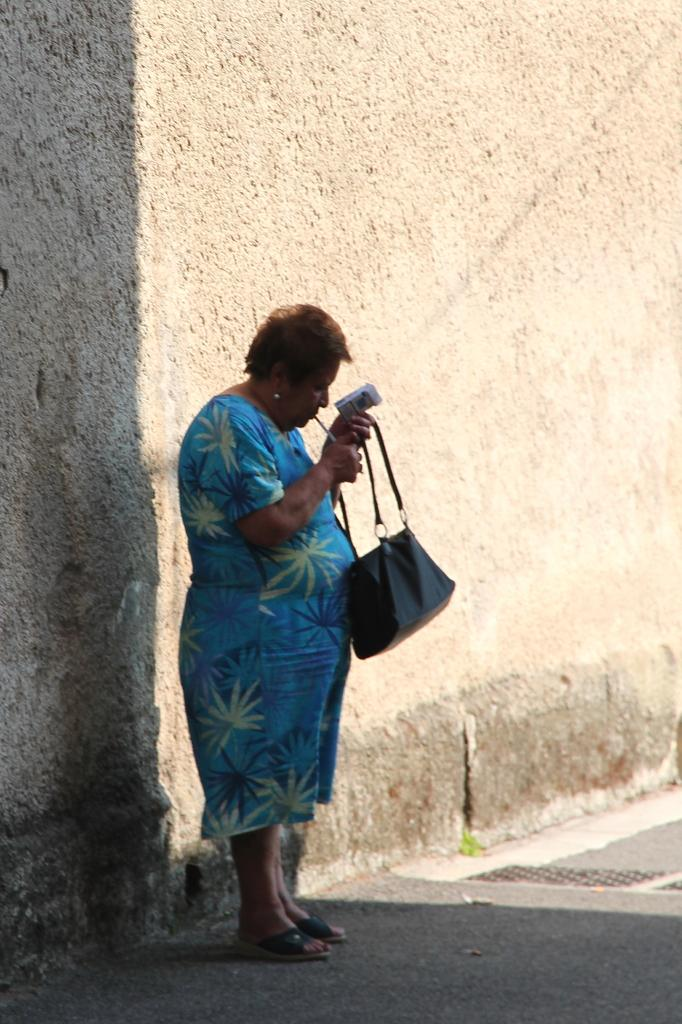Who is present in the image? There is a woman in the image. What is the woman doing in the image? The woman is standing on the road. What is the woman holding in the image? The woman is holding a bag in her hands. What can be seen in the background of the image? There is a wall in the background of the image. What type of prose is the woman reciting in the image? There is no indication in the image that the woman is reciting any prose, so it cannot be determined from the picture. 